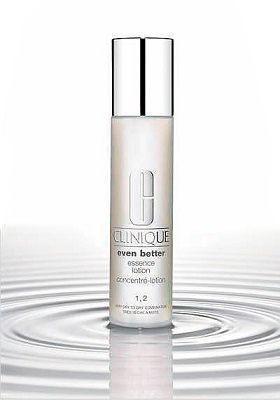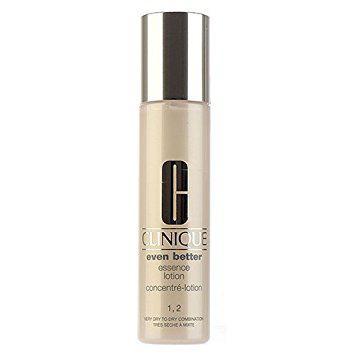The first image is the image on the left, the second image is the image on the right. Given the left and right images, does the statement "An image shows a cylindrical upright bottle creating ripples in a pool of water." hold true? Answer yes or no. Yes. The first image is the image on the left, the second image is the image on the right. Given the left and right images, does the statement "The right image contains no more than one slim container with a chrome top." hold true? Answer yes or no. Yes. 